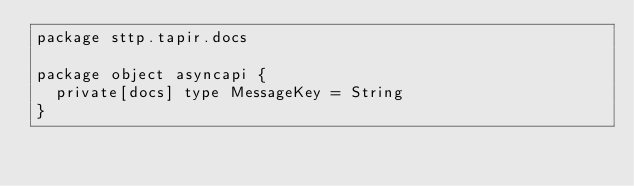Convert code to text. <code><loc_0><loc_0><loc_500><loc_500><_Scala_>package sttp.tapir.docs

package object asyncapi {
  private[docs] type MessageKey = String
}
</code> 